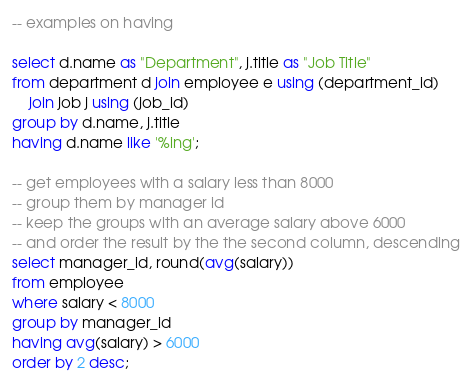Convert code to text. <code><loc_0><loc_0><loc_500><loc_500><_SQL_>-- examples on having

select d.name as "Department", j.title as "Job Title"
from department d join employee e using (department_id)
    join job j using (job_id)
group by d.name, j.title
having d.name like '%ing';

-- get employees with a salary less than 8000
-- group them by manager id
-- keep the groups with an average salary above 6000
-- and order the result by the the second column, descending
select manager_id, round(avg(salary))
from employee
where salary < 8000
group by manager_id
having avg(salary) > 6000
order by 2 desc;
</code> 